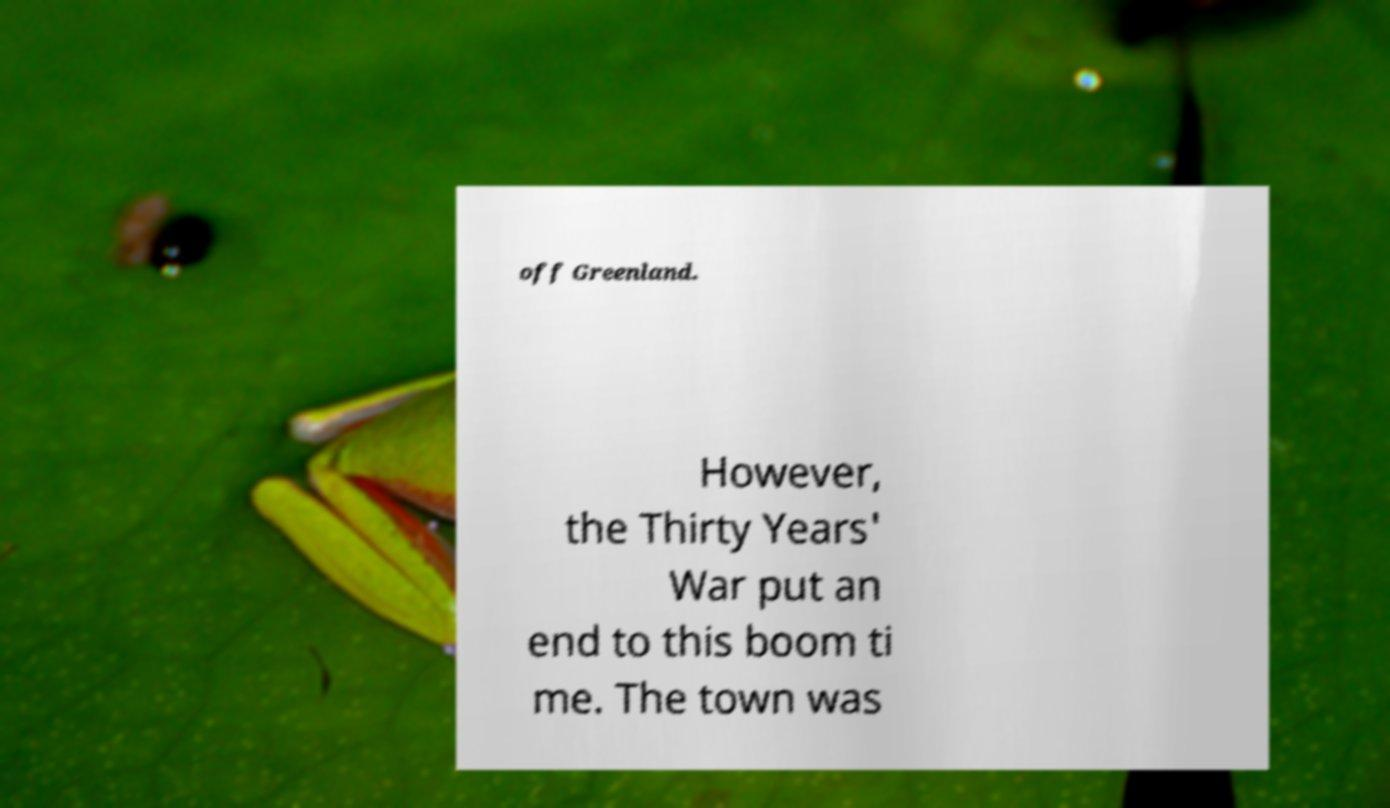I need the written content from this picture converted into text. Can you do that? off Greenland. However, the Thirty Years' War put an end to this boom ti me. The town was 